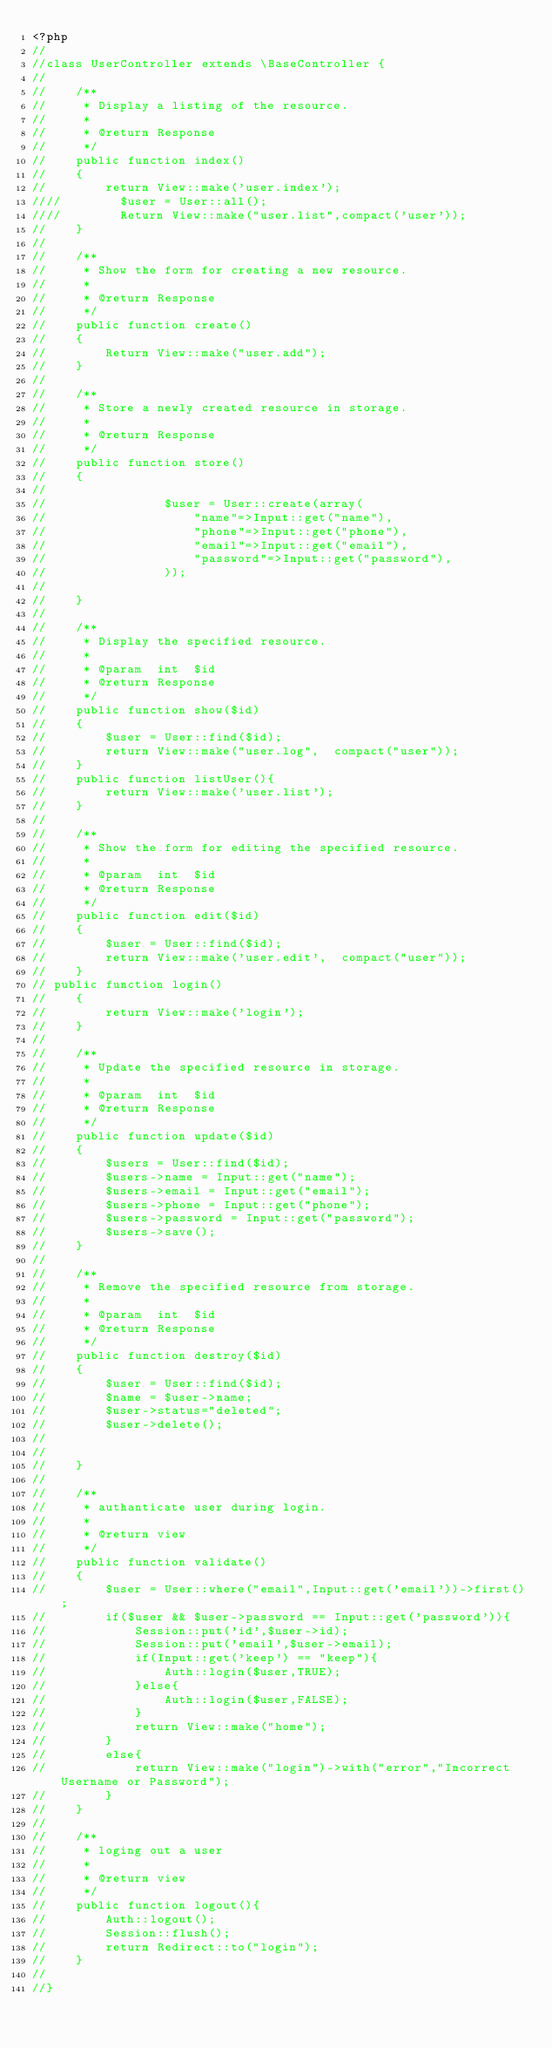Convert code to text. <code><loc_0><loc_0><loc_500><loc_500><_PHP_><?php
//
//class UserController extends \BaseController {
//
//    /**
//     * Display a listing of the resource.
//     *
//     * @return Response
//     */
//    public function index()
//    {
//        return View::make('user.index');
////        $user = User::all();
////        Return View::make("user.list",compact('user'));
//    }
//
//    /**
//     * Show the form for creating a new resource.
//     *
//     * @return Response
//     */
//    public function create()
//    {
//        Return View::make("user.add");
//    }
//
//    /**
//     * Store a newly created resource in storage.
//     *
//     * @return Response
//     */
//    public function store()
//    {
//
//                $user = User::create(array(
//                    "name"=>Input::get("name"),
//                    "phone"=>Input::get("phone"),
//                    "email"=>Input::get("email"),
//                    "password"=>Input::get("password"),
//                ));
//
//    }
//
//    /**
//     * Display the specified resource.
//     *
//     * @param  int  $id
//     * @return Response
//     */
//    public function show($id)
//    {
//        $user = User::find($id);
//        return View::make("user.log",  compact("user"));
//    }
//    public function listUser(){
//        return View::make('user.list');
//    }
//
//    /**
//     * Show the form for editing the specified resource.
//     *
//     * @param  int  $id
//     * @return Response
//     */
//    public function edit($id)
//    {
//        $user = User::find($id);
//        return View::make('user.edit',  compact("user"));
//    }
// public function login()
//    {
//        return View::make('login');
//    }
//
//    /**
//     * Update the specified resource in storage.
//     *
//     * @param  int  $id
//     * @return Response
//     */
//    public function update($id)
//    {
//        $users = User::find($id);
//        $users->name = Input::get("name");
//        $users->email = Input::get("email");
//        $users->phone = Input::get("phone");
//        $users->password = Input::get("password");
//        $users->save();
//    }
//
//    /**
//     * Remove the specified resource from storage.
//     *
//     * @param  int  $id
//     * @return Response
//     */
//    public function destroy($id)
//    {
//        $user = User::find($id);
//        $name = $user->name;
//        $user->status="deleted";
//        $user->delete();
//
//
//    }
//
//    /**
//     * authanticate user during login.
//     *
//     * @return view
//     */
//    public function validate()
//    {
//        $user = User::where("email",Input::get('email'))->first();
//        if($user && $user->password == Input::get('password')){
//            Session::put('id',$user->id);
//            Session::put('email',$user->email);
//            if(Input::get('keep') == "keep"){
//                Auth::login($user,TRUE);
//            }else{
//                Auth::login($user,FALSE);
//            }
//            return View::make("home");
//        }
//        else{
//            return View::make("login")->with("error","Incorrect Username or Password");
//        }
//    }
//
//    /**
//     * loging out a user
//     *
//     * @return view
//     */
//    public function logout(){
//        Auth::logout();
//        Session::flush();
//        return Redirect::to("login");
//    }
//
//}</code> 